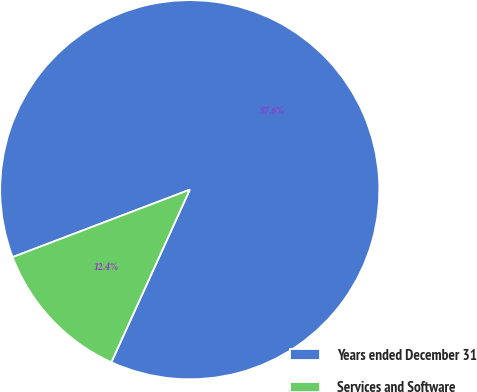<chart> <loc_0><loc_0><loc_500><loc_500><pie_chart><fcel>Years ended December 31<fcel>Services and Software<nl><fcel>87.58%<fcel>12.42%<nl></chart> 